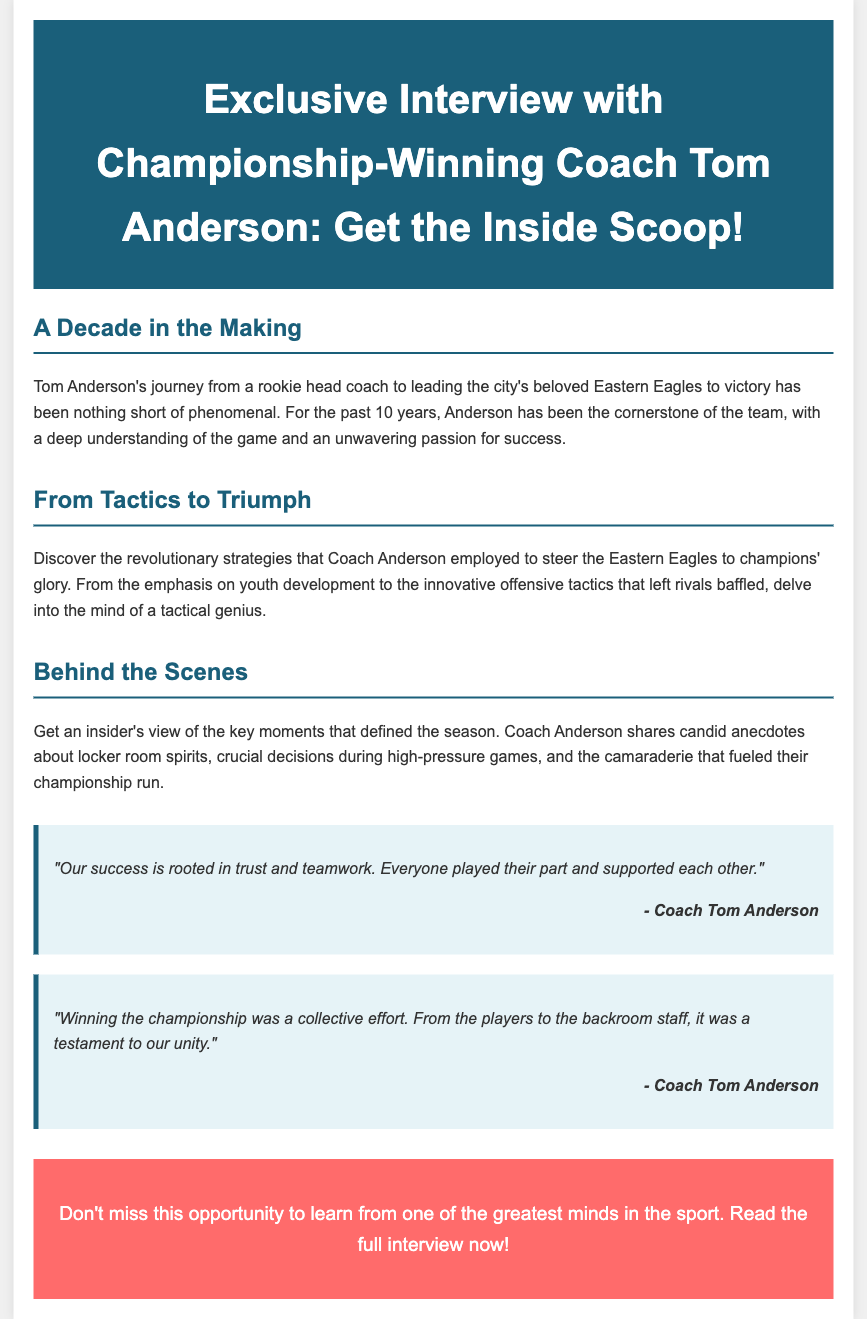What is the coach's name? The document states the coach's name as "Tom Anderson."
Answer: Tom Anderson How many years has Tom Anderson coached the team? The document mentions he has been coaching for "10 years."
Answer: 10 years What is the name of the team coached by Tom Anderson? The document identifies the team as the "Eastern Eagles."
Answer: Eastern Eagles What is the main theme of the interview? The document highlights the interview's focus on "the inside scoop" about Coach Anderson's strategies and experiences.
Answer: Inside scoop What did Coach Anderson emphasize in his coaching strategy? The document states that he emphasized "youth development" among other strategies.
Answer: Youth development What is the color of the header background in the advertisement? The document describes the header background color as "#1a5f7a," a shade of blue.
Answer: #1a5f7a What kind of content can readers expect from the interview? The document promises readers will gain insights into "revolutionary strategies" and "anecdotes about locker room spirits."
Answer: Revolutionary strategies and anecdotes What element highlights Coach Anderson's perspective on teamwork? The document contains a quote from Coach Anderson emphasizing "trust and teamwork."
Answer: Trust and teamwork What type of call-to-action is featured in the document? The document includes a call-to-action inviting readers to "read the full interview now!"
Answer: Read the full interview now! 